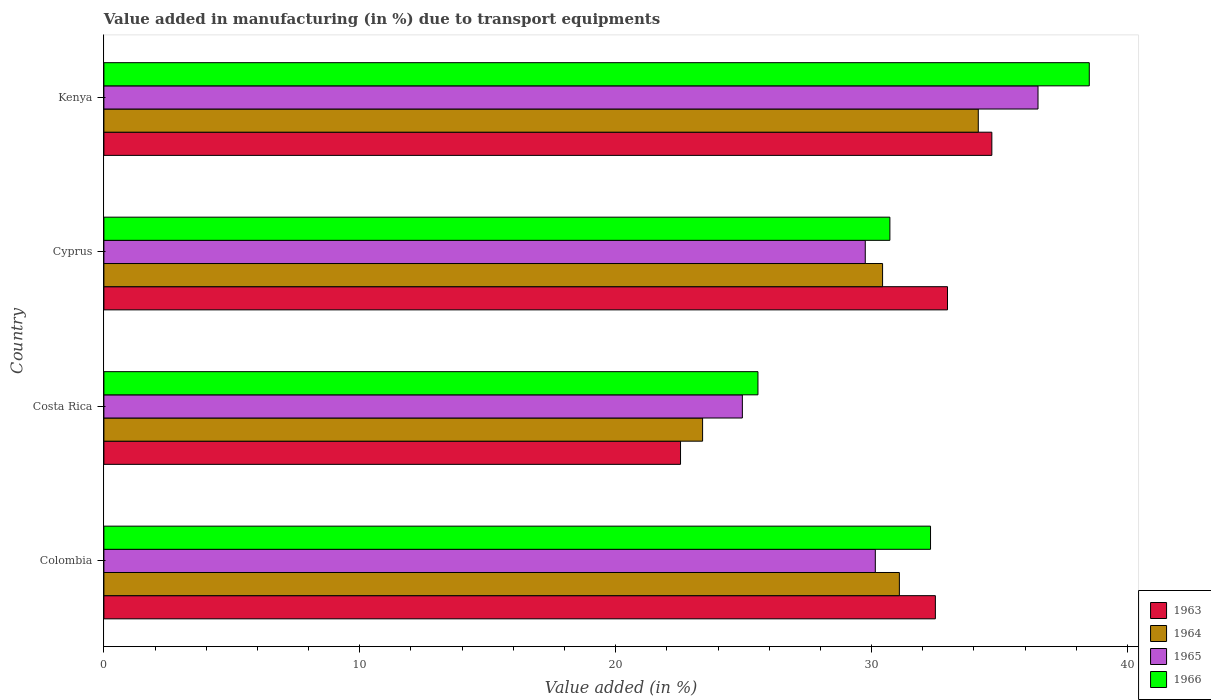How many different coloured bars are there?
Offer a very short reply. 4. How many groups of bars are there?
Ensure brevity in your answer.  4. How many bars are there on the 4th tick from the top?
Your answer should be compact. 4. How many bars are there on the 2nd tick from the bottom?
Offer a terse response. 4. What is the label of the 4th group of bars from the top?
Ensure brevity in your answer.  Colombia. What is the percentage of value added in manufacturing due to transport equipments in 1964 in Costa Rica?
Your answer should be very brief. 23.4. Across all countries, what is the maximum percentage of value added in manufacturing due to transport equipments in 1966?
Offer a terse response. 38.51. Across all countries, what is the minimum percentage of value added in manufacturing due to transport equipments in 1966?
Offer a terse response. 25.56. In which country was the percentage of value added in manufacturing due to transport equipments in 1965 maximum?
Give a very brief answer. Kenya. In which country was the percentage of value added in manufacturing due to transport equipments in 1963 minimum?
Your answer should be very brief. Costa Rica. What is the total percentage of value added in manufacturing due to transport equipments in 1966 in the graph?
Keep it short and to the point. 127.09. What is the difference between the percentage of value added in manufacturing due to transport equipments in 1965 in Colombia and that in Cyprus?
Your answer should be very brief. 0.39. What is the difference between the percentage of value added in manufacturing due to transport equipments in 1966 in Colombia and the percentage of value added in manufacturing due to transport equipments in 1965 in Cyprus?
Your response must be concise. 2.55. What is the average percentage of value added in manufacturing due to transport equipments in 1966 per country?
Provide a short and direct response. 31.77. What is the difference between the percentage of value added in manufacturing due to transport equipments in 1965 and percentage of value added in manufacturing due to transport equipments in 1963 in Kenya?
Keep it short and to the point. 1.8. In how many countries, is the percentage of value added in manufacturing due to transport equipments in 1963 greater than 34 %?
Your response must be concise. 1. What is the ratio of the percentage of value added in manufacturing due to transport equipments in 1966 in Colombia to that in Costa Rica?
Your response must be concise. 1.26. Is the percentage of value added in manufacturing due to transport equipments in 1965 in Costa Rica less than that in Kenya?
Provide a succinct answer. Yes. What is the difference between the highest and the second highest percentage of value added in manufacturing due to transport equipments in 1963?
Keep it short and to the point. 1.73. What is the difference between the highest and the lowest percentage of value added in manufacturing due to transport equipments in 1964?
Your response must be concise. 10.77. In how many countries, is the percentage of value added in manufacturing due to transport equipments in 1966 greater than the average percentage of value added in manufacturing due to transport equipments in 1966 taken over all countries?
Keep it short and to the point. 2. Is it the case that in every country, the sum of the percentage of value added in manufacturing due to transport equipments in 1965 and percentage of value added in manufacturing due to transport equipments in 1964 is greater than the sum of percentage of value added in manufacturing due to transport equipments in 1963 and percentage of value added in manufacturing due to transport equipments in 1966?
Keep it short and to the point. No. What does the 2nd bar from the top in Colombia represents?
Offer a terse response. 1965. What does the 2nd bar from the bottom in Colombia represents?
Offer a terse response. 1964. Are all the bars in the graph horizontal?
Provide a succinct answer. Yes. How many countries are there in the graph?
Provide a short and direct response. 4. What is the difference between two consecutive major ticks on the X-axis?
Offer a terse response. 10. What is the title of the graph?
Your answer should be compact. Value added in manufacturing (in %) due to transport equipments. Does "1992" appear as one of the legend labels in the graph?
Make the answer very short. No. What is the label or title of the X-axis?
Ensure brevity in your answer.  Value added (in %). What is the label or title of the Y-axis?
Ensure brevity in your answer.  Country. What is the Value added (in %) in 1963 in Colombia?
Provide a succinct answer. 32.49. What is the Value added (in %) in 1964 in Colombia?
Your response must be concise. 31.09. What is the Value added (in %) in 1965 in Colombia?
Ensure brevity in your answer.  30.15. What is the Value added (in %) in 1966 in Colombia?
Offer a very short reply. 32.3. What is the Value added (in %) of 1963 in Costa Rica?
Your answer should be very brief. 22.53. What is the Value added (in %) of 1964 in Costa Rica?
Ensure brevity in your answer.  23.4. What is the Value added (in %) of 1965 in Costa Rica?
Your answer should be compact. 24.95. What is the Value added (in %) of 1966 in Costa Rica?
Offer a terse response. 25.56. What is the Value added (in %) of 1963 in Cyprus?
Ensure brevity in your answer.  32.97. What is the Value added (in %) in 1964 in Cyprus?
Keep it short and to the point. 30.43. What is the Value added (in %) of 1965 in Cyprus?
Ensure brevity in your answer.  29.75. What is the Value added (in %) of 1966 in Cyprus?
Offer a very short reply. 30.72. What is the Value added (in %) of 1963 in Kenya?
Ensure brevity in your answer.  34.7. What is the Value added (in %) in 1964 in Kenya?
Your answer should be compact. 34.17. What is the Value added (in %) in 1965 in Kenya?
Your answer should be compact. 36.5. What is the Value added (in %) in 1966 in Kenya?
Ensure brevity in your answer.  38.51. Across all countries, what is the maximum Value added (in %) of 1963?
Offer a very short reply. 34.7. Across all countries, what is the maximum Value added (in %) of 1964?
Your answer should be compact. 34.17. Across all countries, what is the maximum Value added (in %) in 1965?
Offer a very short reply. 36.5. Across all countries, what is the maximum Value added (in %) in 1966?
Provide a succinct answer. 38.51. Across all countries, what is the minimum Value added (in %) of 1963?
Give a very brief answer. 22.53. Across all countries, what is the minimum Value added (in %) in 1964?
Make the answer very short. 23.4. Across all countries, what is the minimum Value added (in %) of 1965?
Your response must be concise. 24.95. Across all countries, what is the minimum Value added (in %) in 1966?
Ensure brevity in your answer.  25.56. What is the total Value added (in %) in 1963 in the graph?
Provide a short and direct response. 122.69. What is the total Value added (in %) of 1964 in the graph?
Make the answer very short. 119.08. What is the total Value added (in %) of 1965 in the graph?
Keep it short and to the point. 121.35. What is the total Value added (in %) of 1966 in the graph?
Offer a very short reply. 127.09. What is the difference between the Value added (in %) of 1963 in Colombia and that in Costa Rica?
Ensure brevity in your answer.  9.96. What is the difference between the Value added (in %) of 1964 in Colombia and that in Costa Rica?
Ensure brevity in your answer.  7.69. What is the difference between the Value added (in %) in 1965 in Colombia and that in Costa Rica?
Provide a succinct answer. 5.2. What is the difference between the Value added (in %) in 1966 in Colombia and that in Costa Rica?
Offer a very short reply. 6.74. What is the difference between the Value added (in %) of 1963 in Colombia and that in Cyprus?
Offer a terse response. -0.47. What is the difference between the Value added (in %) of 1964 in Colombia and that in Cyprus?
Make the answer very short. 0.66. What is the difference between the Value added (in %) in 1965 in Colombia and that in Cyprus?
Keep it short and to the point. 0.39. What is the difference between the Value added (in %) of 1966 in Colombia and that in Cyprus?
Keep it short and to the point. 1.59. What is the difference between the Value added (in %) in 1963 in Colombia and that in Kenya?
Make the answer very short. -2.21. What is the difference between the Value added (in %) of 1964 in Colombia and that in Kenya?
Provide a succinct answer. -3.08. What is the difference between the Value added (in %) of 1965 in Colombia and that in Kenya?
Your answer should be compact. -6.36. What is the difference between the Value added (in %) of 1966 in Colombia and that in Kenya?
Ensure brevity in your answer.  -6.2. What is the difference between the Value added (in %) of 1963 in Costa Rica and that in Cyprus?
Make the answer very short. -10.43. What is the difference between the Value added (in %) of 1964 in Costa Rica and that in Cyprus?
Your response must be concise. -7.03. What is the difference between the Value added (in %) in 1965 in Costa Rica and that in Cyprus?
Ensure brevity in your answer.  -4.8. What is the difference between the Value added (in %) of 1966 in Costa Rica and that in Cyprus?
Your answer should be very brief. -5.16. What is the difference between the Value added (in %) of 1963 in Costa Rica and that in Kenya?
Offer a terse response. -12.17. What is the difference between the Value added (in %) in 1964 in Costa Rica and that in Kenya?
Your response must be concise. -10.77. What is the difference between the Value added (in %) of 1965 in Costa Rica and that in Kenya?
Your answer should be compact. -11.55. What is the difference between the Value added (in %) of 1966 in Costa Rica and that in Kenya?
Your response must be concise. -12.95. What is the difference between the Value added (in %) in 1963 in Cyprus and that in Kenya?
Your response must be concise. -1.73. What is the difference between the Value added (in %) in 1964 in Cyprus and that in Kenya?
Make the answer very short. -3.74. What is the difference between the Value added (in %) in 1965 in Cyprus and that in Kenya?
Your answer should be compact. -6.75. What is the difference between the Value added (in %) in 1966 in Cyprus and that in Kenya?
Ensure brevity in your answer.  -7.79. What is the difference between the Value added (in %) of 1963 in Colombia and the Value added (in %) of 1964 in Costa Rica?
Make the answer very short. 9.1. What is the difference between the Value added (in %) in 1963 in Colombia and the Value added (in %) in 1965 in Costa Rica?
Keep it short and to the point. 7.54. What is the difference between the Value added (in %) in 1963 in Colombia and the Value added (in %) in 1966 in Costa Rica?
Your response must be concise. 6.93. What is the difference between the Value added (in %) in 1964 in Colombia and the Value added (in %) in 1965 in Costa Rica?
Your answer should be very brief. 6.14. What is the difference between the Value added (in %) of 1964 in Colombia and the Value added (in %) of 1966 in Costa Rica?
Offer a terse response. 5.53. What is the difference between the Value added (in %) of 1965 in Colombia and the Value added (in %) of 1966 in Costa Rica?
Provide a short and direct response. 4.59. What is the difference between the Value added (in %) of 1963 in Colombia and the Value added (in %) of 1964 in Cyprus?
Make the answer very short. 2.06. What is the difference between the Value added (in %) in 1963 in Colombia and the Value added (in %) in 1965 in Cyprus?
Your answer should be compact. 2.74. What is the difference between the Value added (in %) in 1963 in Colombia and the Value added (in %) in 1966 in Cyprus?
Give a very brief answer. 1.78. What is the difference between the Value added (in %) in 1964 in Colombia and the Value added (in %) in 1965 in Cyprus?
Make the answer very short. 1.33. What is the difference between the Value added (in %) in 1964 in Colombia and the Value added (in %) in 1966 in Cyprus?
Offer a very short reply. 0.37. What is the difference between the Value added (in %) of 1965 in Colombia and the Value added (in %) of 1966 in Cyprus?
Provide a short and direct response. -0.57. What is the difference between the Value added (in %) of 1963 in Colombia and the Value added (in %) of 1964 in Kenya?
Provide a short and direct response. -1.68. What is the difference between the Value added (in %) of 1963 in Colombia and the Value added (in %) of 1965 in Kenya?
Offer a terse response. -4.01. What is the difference between the Value added (in %) of 1963 in Colombia and the Value added (in %) of 1966 in Kenya?
Provide a short and direct response. -6.01. What is the difference between the Value added (in %) in 1964 in Colombia and the Value added (in %) in 1965 in Kenya?
Make the answer very short. -5.42. What is the difference between the Value added (in %) in 1964 in Colombia and the Value added (in %) in 1966 in Kenya?
Offer a very short reply. -7.42. What is the difference between the Value added (in %) in 1965 in Colombia and the Value added (in %) in 1966 in Kenya?
Your answer should be very brief. -8.36. What is the difference between the Value added (in %) in 1963 in Costa Rica and the Value added (in %) in 1964 in Cyprus?
Offer a terse response. -7.9. What is the difference between the Value added (in %) of 1963 in Costa Rica and the Value added (in %) of 1965 in Cyprus?
Offer a terse response. -7.22. What is the difference between the Value added (in %) of 1963 in Costa Rica and the Value added (in %) of 1966 in Cyprus?
Ensure brevity in your answer.  -8.18. What is the difference between the Value added (in %) in 1964 in Costa Rica and the Value added (in %) in 1965 in Cyprus?
Offer a terse response. -6.36. What is the difference between the Value added (in %) in 1964 in Costa Rica and the Value added (in %) in 1966 in Cyprus?
Make the answer very short. -7.32. What is the difference between the Value added (in %) in 1965 in Costa Rica and the Value added (in %) in 1966 in Cyprus?
Provide a short and direct response. -5.77. What is the difference between the Value added (in %) of 1963 in Costa Rica and the Value added (in %) of 1964 in Kenya?
Keep it short and to the point. -11.64. What is the difference between the Value added (in %) in 1963 in Costa Rica and the Value added (in %) in 1965 in Kenya?
Give a very brief answer. -13.97. What is the difference between the Value added (in %) of 1963 in Costa Rica and the Value added (in %) of 1966 in Kenya?
Offer a very short reply. -15.97. What is the difference between the Value added (in %) in 1964 in Costa Rica and the Value added (in %) in 1965 in Kenya?
Your response must be concise. -13.11. What is the difference between the Value added (in %) of 1964 in Costa Rica and the Value added (in %) of 1966 in Kenya?
Offer a very short reply. -15.11. What is the difference between the Value added (in %) of 1965 in Costa Rica and the Value added (in %) of 1966 in Kenya?
Ensure brevity in your answer.  -13.56. What is the difference between the Value added (in %) of 1963 in Cyprus and the Value added (in %) of 1964 in Kenya?
Offer a very short reply. -1.2. What is the difference between the Value added (in %) of 1963 in Cyprus and the Value added (in %) of 1965 in Kenya?
Offer a very short reply. -3.54. What is the difference between the Value added (in %) of 1963 in Cyprus and the Value added (in %) of 1966 in Kenya?
Ensure brevity in your answer.  -5.54. What is the difference between the Value added (in %) in 1964 in Cyprus and the Value added (in %) in 1965 in Kenya?
Your answer should be very brief. -6.07. What is the difference between the Value added (in %) in 1964 in Cyprus and the Value added (in %) in 1966 in Kenya?
Make the answer very short. -8.08. What is the difference between the Value added (in %) of 1965 in Cyprus and the Value added (in %) of 1966 in Kenya?
Your answer should be compact. -8.75. What is the average Value added (in %) of 1963 per country?
Your response must be concise. 30.67. What is the average Value added (in %) in 1964 per country?
Keep it short and to the point. 29.77. What is the average Value added (in %) of 1965 per country?
Make the answer very short. 30.34. What is the average Value added (in %) in 1966 per country?
Provide a succinct answer. 31.77. What is the difference between the Value added (in %) in 1963 and Value added (in %) in 1964 in Colombia?
Your response must be concise. 1.41. What is the difference between the Value added (in %) in 1963 and Value added (in %) in 1965 in Colombia?
Your answer should be very brief. 2.35. What is the difference between the Value added (in %) in 1963 and Value added (in %) in 1966 in Colombia?
Your answer should be very brief. 0.19. What is the difference between the Value added (in %) in 1964 and Value added (in %) in 1965 in Colombia?
Your answer should be compact. 0.94. What is the difference between the Value added (in %) in 1964 and Value added (in %) in 1966 in Colombia?
Your response must be concise. -1.22. What is the difference between the Value added (in %) in 1965 and Value added (in %) in 1966 in Colombia?
Provide a short and direct response. -2.16. What is the difference between the Value added (in %) in 1963 and Value added (in %) in 1964 in Costa Rica?
Provide a succinct answer. -0.86. What is the difference between the Value added (in %) in 1963 and Value added (in %) in 1965 in Costa Rica?
Keep it short and to the point. -2.42. What is the difference between the Value added (in %) in 1963 and Value added (in %) in 1966 in Costa Rica?
Keep it short and to the point. -3.03. What is the difference between the Value added (in %) of 1964 and Value added (in %) of 1965 in Costa Rica?
Give a very brief answer. -1.55. What is the difference between the Value added (in %) in 1964 and Value added (in %) in 1966 in Costa Rica?
Your response must be concise. -2.16. What is the difference between the Value added (in %) in 1965 and Value added (in %) in 1966 in Costa Rica?
Give a very brief answer. -0.61. What is the difference between the Value added (in %) of 1963 and Value added (in %) of 1964 in Cyprus?
Your response must be concise. 2.54. What is the difference between the Value added (in %) in 1963 and Value added (in %) in 1965 in Cyprus?
Ensure brevity in your answer.  3.21. What is the difference between the Value added (in %) in 1963 and Value added (in %) in 1966 in Cyprus?
Provide a succinct answer. 2.25. What is the difference between the Value added (in %) in 1964 and Value added (in %) in 1965 in Cyprus?
Your answer should be compact. 0.68. What is the difference between the Value added (in %) in 1964 and Value added (in %) in 1966 in Cyprus?
Give a very brief answer. -0.29. What is the difference between the Value added (in %) of 1965 and Value added (in %) of 1966 in Cyprus?
Ensure brevity in your answer.  -0.96. What is the difference between the Value added (in %) of 1963 and Value added (in %) of 1964 in Kenya?
Give a very brief answer. 0.53. What is the difference between the Value added (in %) in 1963 and Value added (in %) in 1965 in Kenya?
Provide a succinct answer. -1.8. What is the difference between the Value added (in %) of 1963 and Value added (in %) of 1966 in Kenya?
Keep it short and to the point. -3.81. What is the difference between the Value added (in %) of 1964 and Value added (in %) of 1965 in Kenya?
Give a very brief answer. -2.33. What is the difference between the Value added (in %) of 1964 and Value added (in %) of 1966 in Kenya?
Your answer should be compact. -4.34. What is the difference between the Value added (in %) in 1965 and Value added (in %) in 1966 in Kenya?
Make the answer very short. -2. What is the ratio of the Value added (in %) in 1963 in Colombia to that in Costa Rica?
Your response must be concise. 1.44. What is the ratio of the Value added (in %) in 1964 in Colombia to that in Costa Rica?
Offer a very short reply. 1.33. What is the ratio of the Value added (in %) of 1965 in Colombia to that in Costa Rica?
Keep it short and to the point. 1.21. What is the ratio of the Value added (in %) in 1966 in Colombia to that in Costa Rica?
Offer a very short reply. 1.26. What is the ratio of the Value added (in %) of 1963 in Colombia to that in Cyprus?
Your answer should be compact. 0.99. What is the ratio of the Value added (in %) in 1964 in Colombia to that in Cyprus?
Provide a short and direct response. 1.02. What is the ratio of the Value added (in %) in 1965 in Colombia to that in Cyprus?
Your answer should be compact. 1.01. What is the ratio of the Value added (in %) of 1966 in Colombia to that in Cyprus?
Offer a terse response. 1.05. What is the ratio of the Value added (in %) in 1963 in Colombia to that in Kenya?
Keep it short and to the point. 0.94. What is the ratio of the Value added (in %) of 1964 in Colombia to that in Kenya?
Ensure brevity in your answer.  0.91. What is the ratio of the Value added (in %) in 1965 in Colombia to that in Kenya?
Your response must be concise. 0.83. What is the ratio of the Value added (in %) in 1966 in Colombia to that in Kenya?
Offer a terse response. 0.84. What is the ratio of the Value added (in %) of 1963 in Costa Rica to that in Cyprus?
Offer a terse response. 0.68. What is the ratio of the Value added (in %) in 1964 in Costa Rica to that in Cyprus?
Provide a succinct answer. 0.77. What is the ratio of the Value added (in %) in 1965 in Costa Rica to that in Cyprus?
Give a very brief answer. 0.84. What is the ratio of the Value added (in %) of 1966 in Costa Rica to that in Cyprus?
Provide a succinct answer. 0.83. What is the ratio of the Value added (in %) in 1963 in Costa Rica to that in Kenya?
Keep it short and to the point. 0.65. What is the ratio of the Value added (in %) of 1964 in Costa Rica to that in Kenya?
Give a very brief answer. 0.68. What is the ratio of the Value added (in %) of 1965 in Costa Rica to that in Kenya?
Keep it short and to the point. 0.68. What is the ratio of the Value added (in %) in 1966 in Costa Rica to that in Kenya?
Your response must be concise. 0.66. What is the ratio of the Value added (in %) of 1963 in Cyprus to that in Kenya?
Offer a terse response. 0.95. What is the ratio of the Value added (in %) of 1964 in Cyprus to that in Kenya?
Offer a very short reply. 0.89. What is the ratio of the Value added (in %) of 1965 in Cyprus to that in Kenya?
Provide a succinct answer. 0.82. What is the ratio of the Value added (in %) in 1966 in Cyprus to that in Kenya?
Your answer should be very brief. 0.8. What is the difference between the highest and the second highest Value added (in %) of 1963?
Your answer should be compact. 1.73. What is the difference between the highest and the second highest Value added (in %) in 1964?
Provide a succinct answer. 3.08. What is the difference between the highest and the second highest Value added (in %) in 1965?
Ensure brevity in your answer.  6.36. What is the difference between the highest and the second highest Value added (in %) in 1966?
Offer a terse response. 6.2. What is the difference between the highest and the lowest Value added (in %) in 1963?
Provide a succinct answer. 12.17. What is the difference between the highest and the lowest Value added (in %) of 1964?
Your response must be concise. 10.77. What is the difference between the highest and the lowest Value added (in %) in 1965?
Offer a terse response. 11.55. What is the difference between the highest and the lowest Value added (in %) of 1966?
Ensure brevity in your answer.  12.95. 